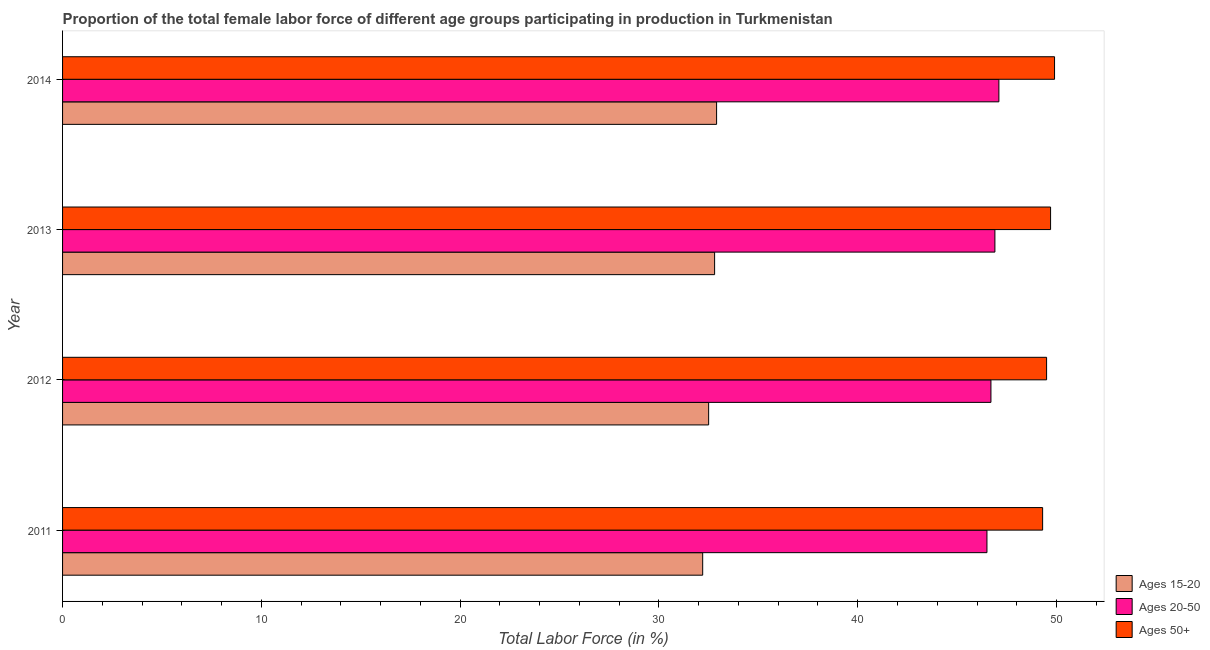How many groups of bars are there?
Ensure brevity in your answer.  4. Are the number of bars on each tick of the Y-axis equal?
Your answer should be very brief. Yes. How many bars are there on the 4th tick from the top?
Your answer should be very brief. 3. In how many cases, is the number of bars for a given year not equal to the number of legend labels?
Your response must be concise. 0. What is the percentage of female labor force above age 50 in 2012?
Your response must be concise. 49.5. Across all years, what is the maximum percentage of female labor force above age 50?
Provide a succinct answer. 49.9. Across all years, what is the minimum percentage of female labor force within the age group 15-20?
Offer a very short reply. 32.2. In which year was the percentage of female labor force within the age group 20-50 maximum?
Provide a succinct answer. 2014. What is the total percentage of female labor force within the age group 15-20 in the graph?
Give a very brief answer. 130.4. What is the difference between the percentage of female labor force above age 50 in 2011 and that in 2014?
Provide a short and direct response. -0.6. What is the difference between the percentage of female labor force above age 50 in 2014 and the percentage of female labor force within the age group 15-20 in 2011?
Give a very brief answer. 17.7. What is the average percentage of female labor force within the age group 15-20 per year?
Make the answer very short. 32.6. In the year 2011, what is the difference between the percentage of female labor force above age 50 and percentage of female labor force within the age group 20-50?
Your answer should be compact. 2.8. In how many years, is the percentage of female labor force within the age group 15-20 greater than 44 %?
Keep it short and to the point. 0. Is the percentage of female labor force within the age group 20-50 in 2011 less than that in 2014?
Make the answer very short. Yes. Is the difference between the percentage of female labor force within the age group 15-20 in 2012 and 2013 greater than the difference between the percentage of female labor force within the age group 20-50 in 2012 and 2013?
Keep it short and to the point. No. What is the difference between the highest and the second highest percentage of female labor force within the age group 15-20?
Offer a very short reply. 0.1. What is the difference between the highest and the lowest percentage of female labor force above age 50?
Your response must be concise. 0.6. What does the 3rd bar from the top in 2011 represents?
Keep it short and to the point. Ages 15-20. What does the 1st bar from the bottom in 2014 represents?
Offer a terse response. Ages 15-20. Is it the case that in every year, the sum of the percentage of female labor force within the age group 15-20 and percentage of female labor force within the age group 20-50 is greater than the percentage of female labor force above age 50?
Your response must be concise. Yes. How many bars are there?
Give a very brief answer. 12. How many years are there in the graph?
Ensure brevity in your answer.  4. Are the values on the major ticks of X-axis written in scientific E-notation?
Offer a very short reply. No. Does the graph contain any zero values?
Ensure brevity in your answer.  No. Where does the legend appear in the graph?
Ensure brevity in your answer.  Bottom right. How many legend labels are there?
Give a very brief answer. 3. What is the title of the graph?
Your answer should be compact. Proportion of the total female labor force of different age groups participating in production in Turkmenistan. Does "Tertiary education" appear as one of the legend labels in the graph?
Make the answer very short. No. What is the label or title of the Y-axis?
Ensure brevity in your answer.  Year. What is the Total Labor Force (in %) in Ages 15-20 in 2011?
Offer a very short reply. 32.2. What is the Total Labor Force (in %) in Ages 20-50 in 2011?
Keep it short and to the point. 46.5. What is the Total Labor Force (in %) in Ages 50+ in 2011?
Make the answer very short. 49.3. What is the Total Labor Force (in %) in Ages 15-20 in 2012?
Provide a short and direct response. 32.5. What is the Total Labor Force (in %) in Ages 20-50 in 2012?
Provide a short and direct response. 46.7. What is the Total Labor Force (in %) of Ages 50+ in 2012?
Your answer should be compact. 49.5. What is the Total Labor Force (in %) in Ages 15-20 in 2013?
Ensure brevity in your answer.  32.8. What is the Total Labor Force (in %) of Ages 20-50 in 2013?
Your answer should be very brief. 46.9. What is the Total Labor Force (in %) of Ages 50+ in 2013?
Your answer should be compact. 49.7. What is the Total Labor Force (in %) in Ages 15-20 in 2014?
Provide a succinct answer. 32.9. What is the Total Labor Force (in %) in Ages 20-50 in 2014?
Keep it short and to the point. 47.1. What is the Total Labor Force (in %) of Ages 50+ in 2014?
Offer a very short reply. 49.9. Across all years, what is the maximum Total Labor Force (in %) in Ages 15-20?
Ensure brevity in your answer.  32.9. Across all years, what is the maximum Total Labor Force (in %) in Ages 20-50?
Ensure brevity in your answer.  47.1. Across all years, what is the maximum Total Labor Force (in %) in Ages 50+?
Offer a terse response. 49.9. Across all years, what is the minimum Total Labor Force (in %) of Ages 15-20?
Make the answer very short. 32.2. Across all years, what is the minimum Total Labor Force (in %) of Ages 20-50?
Give a very brief answer. 46.5. Across all years, what is the minimum Total Labor Force (in %) in Ages 50+?
Offer a terse response. 49.3. What is the total Total Labor Force (in %) in Ages 15-20 in the graph?
Make the answer very short. 130.4. What is the total Total Labor Force (in %) of Ages 20-50 in the graph?
Make the answer very short. 187.2. What is the total Total Labor Force (in %) in Ages 50+ in the graph?
Your answer should be very brief. 198.4. What is the difference between the Total Labor Force (in %) in Ages 15-20 in 2011 and that in 2012?
Ensure brevity in your answer.  -0.3. What is the difference between the Total Labor Force (in %) in Ages 50+ in 2011 and that in 2012?
Provide a succinct answer. -0.2. What is the difference between the Total Labor Force (in %) of Ages 15-20 in 2011 and that in 2013?
Keep it short and to the point. -0.6. What is the difference between the Total Labor Force (in %) in Ages 20-50 in 2011 and that in 2014?
Give a very brief answer. -0.6. What is the difference between the Total Labor Force (in %) in Ages 50+ in 2011 and that in 2014?
Provide a short and direct response. -0.6. What is the difference between the Total Labor Force (in %) of Ages 15-20 in 2012 and that in 2014?
Your answer should be compact. -0.4. What is the difference between the Total Labor Force (in %) in Ages 20-50 in 2012 and that in 2014?
Offer a terse response. -0.4. What is the difference between the Total Labor Force (in %) in Ages 20-50 in 2013 and that in 2014?
Make the answer very short. -0.2. What is the difference between the Total Labor Force (in %) in Ages 50+ in 2013 and that in 2014?
Make the answer very short. -0.2. What is the difference between the Total Labor Force (in %) of Ages 15-20 in 2011 and the Total Labor Force (in %) of Ages 50+ in 2012?
Give a very brief answer. -17.3. What is the difference between the Total Labor Force (in %) of Ages 15-20 in 2011 and the Total Labor Force (in %) of Ages 20-50 in 2013?
Your answer should be compact. -14.7. What is the difference between the Total Labor Force (in %) in Ages 15-20 in 2011 and the Total Labor Force (in %) in Ages 50+ in 2013?
Provide a succinct answer. -17.5. What is the difference between the Total Labor Force (in %) of Ages 15-20 in 2011 and the Total Labor Force (in %) of Ages 20-50 in 2014?
Your response must be concise. -14.9. What is the difference between the Total Labor Force (in %) in Ages 15-20 in 2011 and the Total Labor Force (in %) in Ages 50+ in 2014?
Your answer should be very brief. -17.7. What is the difference between the Total Labor Force (in %) of Ages 15-20 in 2012 and the Total Labor Force (in %) of Ages 20-50 in 2013?
Make the answer very short. -14.4. What is the difference between the Total Labor Force (in %) of Ages 15-20 in 2012 and the Total Labor Force (in %) of Ages 50+ in 2013?
Offer a very short reply. -17.2. What is the difference between the Total Labor Force (in %) of Ages 15-20 in 2012 and the Total Labor Force (in %) of Ages 20-50 in 2014?
Make the answer very short. -14.6. What is the difference between the Total Labor Force (in %) in Ages 15-20 in 2012 and the Total Labor Force (in %) in Ages 50+ in 2014?
Keep it short and to the point. -17.4. What is the difference between the Total Labor Force (in %) in Ages 15-20 in 2013 and the Total Labor Force (in %) in Ages 20-50 in 2014?
Offer a very short reply. -14.3. What is the difference between the Total Labor Force (in %) of Ages 15-20 in 2013 and the Total Labor Force (in %) of Ages 50+ in 2014?
Your answer should be very brief. -17.1. What is the average Total Labor Force (in %) of Ages 15-20 per year?
Your answer should be compact. 32.6. What is the average Total Labor Force (in %) of Ages 20-50 per year?
Your response must be concise. 46.8. What is the average Total Labor Force (in %) of Ages 50+ per year?
Make the answer very short. 49.6. In the year 2011, what is the difference between the Total Labor Force (in %) in Ages 15-20 and Total Labor Force (in %) in Ages 20-50?
Keep it short and to the point. -14.3. In the year 2011, what is the difference between the Total Labor Force (in %) in Ages 15-20 and Total Labor Force (in %) in Ages 50+?
Give a very brief answer. -17.1. In the year 2012, what is the difference between the Total Labor Force (in %) of Ages 15-20 and Total Labor Force (in %) of Ages 20-50?
Keep it short and to the point. -14.2. In the year 2012, what is the difference between the Total Labor Force (in %) in Ages 20-50 and Total Labor Force (in %) in Ages 50+?
Keep it short and to the point. -2.8. In the year 2013, what is the difference between the Total Labor Force (in %) in Ages 15-20 and Total Labor Force (in %) in Ages 20-50?
Provide a succinct answer. -14.1. In the year 2013, what is the difference between the Total Labor Force (in %) in Ages 15-20 and Total Labor Force (in %) in Ages 50+?
Ensure brevity in your answer.  -16.9. In the year 2013, what is the difference between the Total Labor Force (in %) of Ages 20-50 and Total Labor Force (in %) of Ages 50+?
Make the answer very short. -2.8. In the year 2014, what is the difference between the Total Labor Force (in %) of Ages 15-20 and Total Labor Force (in %) of Ages 20-50?
Your response must be concise. -14.2. What is the ratio of the Total Labor Force (in %) of Ages 50+ in 2011 to that in 2012?
Provide a succinct answer. 1. What is the ratio of the Total Labor Force (in %) in Ages 15-20 in 2011 to that in 2013?
Your response must be concise. 0.98. What is the ratio of the Total Labor Force (in %) in Ages 50+ in 2011 to that in 2013?
Offer a terse response. 0.99. What is the ratio of the Total Labor Force (in %) in Ages 15-20 in 2011 to that in 2014?
Keep it short and to the point. 0.98. What is the ratio of the Total Labor Force (in %) in Ages 20-50 in 2011 to that in 2014?
Offer a very short reply. 0.99. What is the ratio of the Total Labor Force (in %) in Ages 50+ in 2011 to that in 2014?
Give a very brief answer. 0.99. What is the ratio of the Total Labor Force (in %) in Ages 15-20 in 2012 to that in 2013?
Your answer should be very brief. 0.99. What is the ratio of the Total Labor Force (in %) in Ages 50+ in 2012 to that in 2013?
Give a very brief answer. 1. What is the ratio of the Total Labor Force (in %) in Ages 15-20 in 2012 to that in 2014?
Your answer should be compact. 0.99. What is the ratio of the Total Labor Force (in %) of Ages 20-50 in 2012 to that in 2014?
Your response must be concise. 0.99. What is the ratio of the Total Labor Force (in %) of Ages 50+ in 2012 to that in 2014?
Offer a very short reply. 0.99. What is the ratio of the Total Labor Force (in %) of Ages 15-20 in 2013 to that in 2014?
Provide a short and direct response. 1. What is the ratio of the Total Labor Force (in %) of Ages 20-50 in 2013 to that in 2014?
Offer a terse response. 1. What is the ratio of the Total Labor Force (in %) in Ages 50+ in 2013 to that in 2014?
Your answer should be compact. 1. What is the difference between the highest and the second highest Total Labor Force (in %) of Ages 15-20?
Provide a succinct answer. 0.1. What is the difference between the highest and the second highest Total Labor Force (in %) of Ages 20-50?
Offer a terse response. 0.2. What is the difference between the highest and the second highest Total Labor Force (in %) of Ages 50+?
Offer a very short reply. 0.2. What is the difference between the highest and the lowest Total Labor Force (in %) in Ages 15-20?
Give a very brief answer. 0.7. 